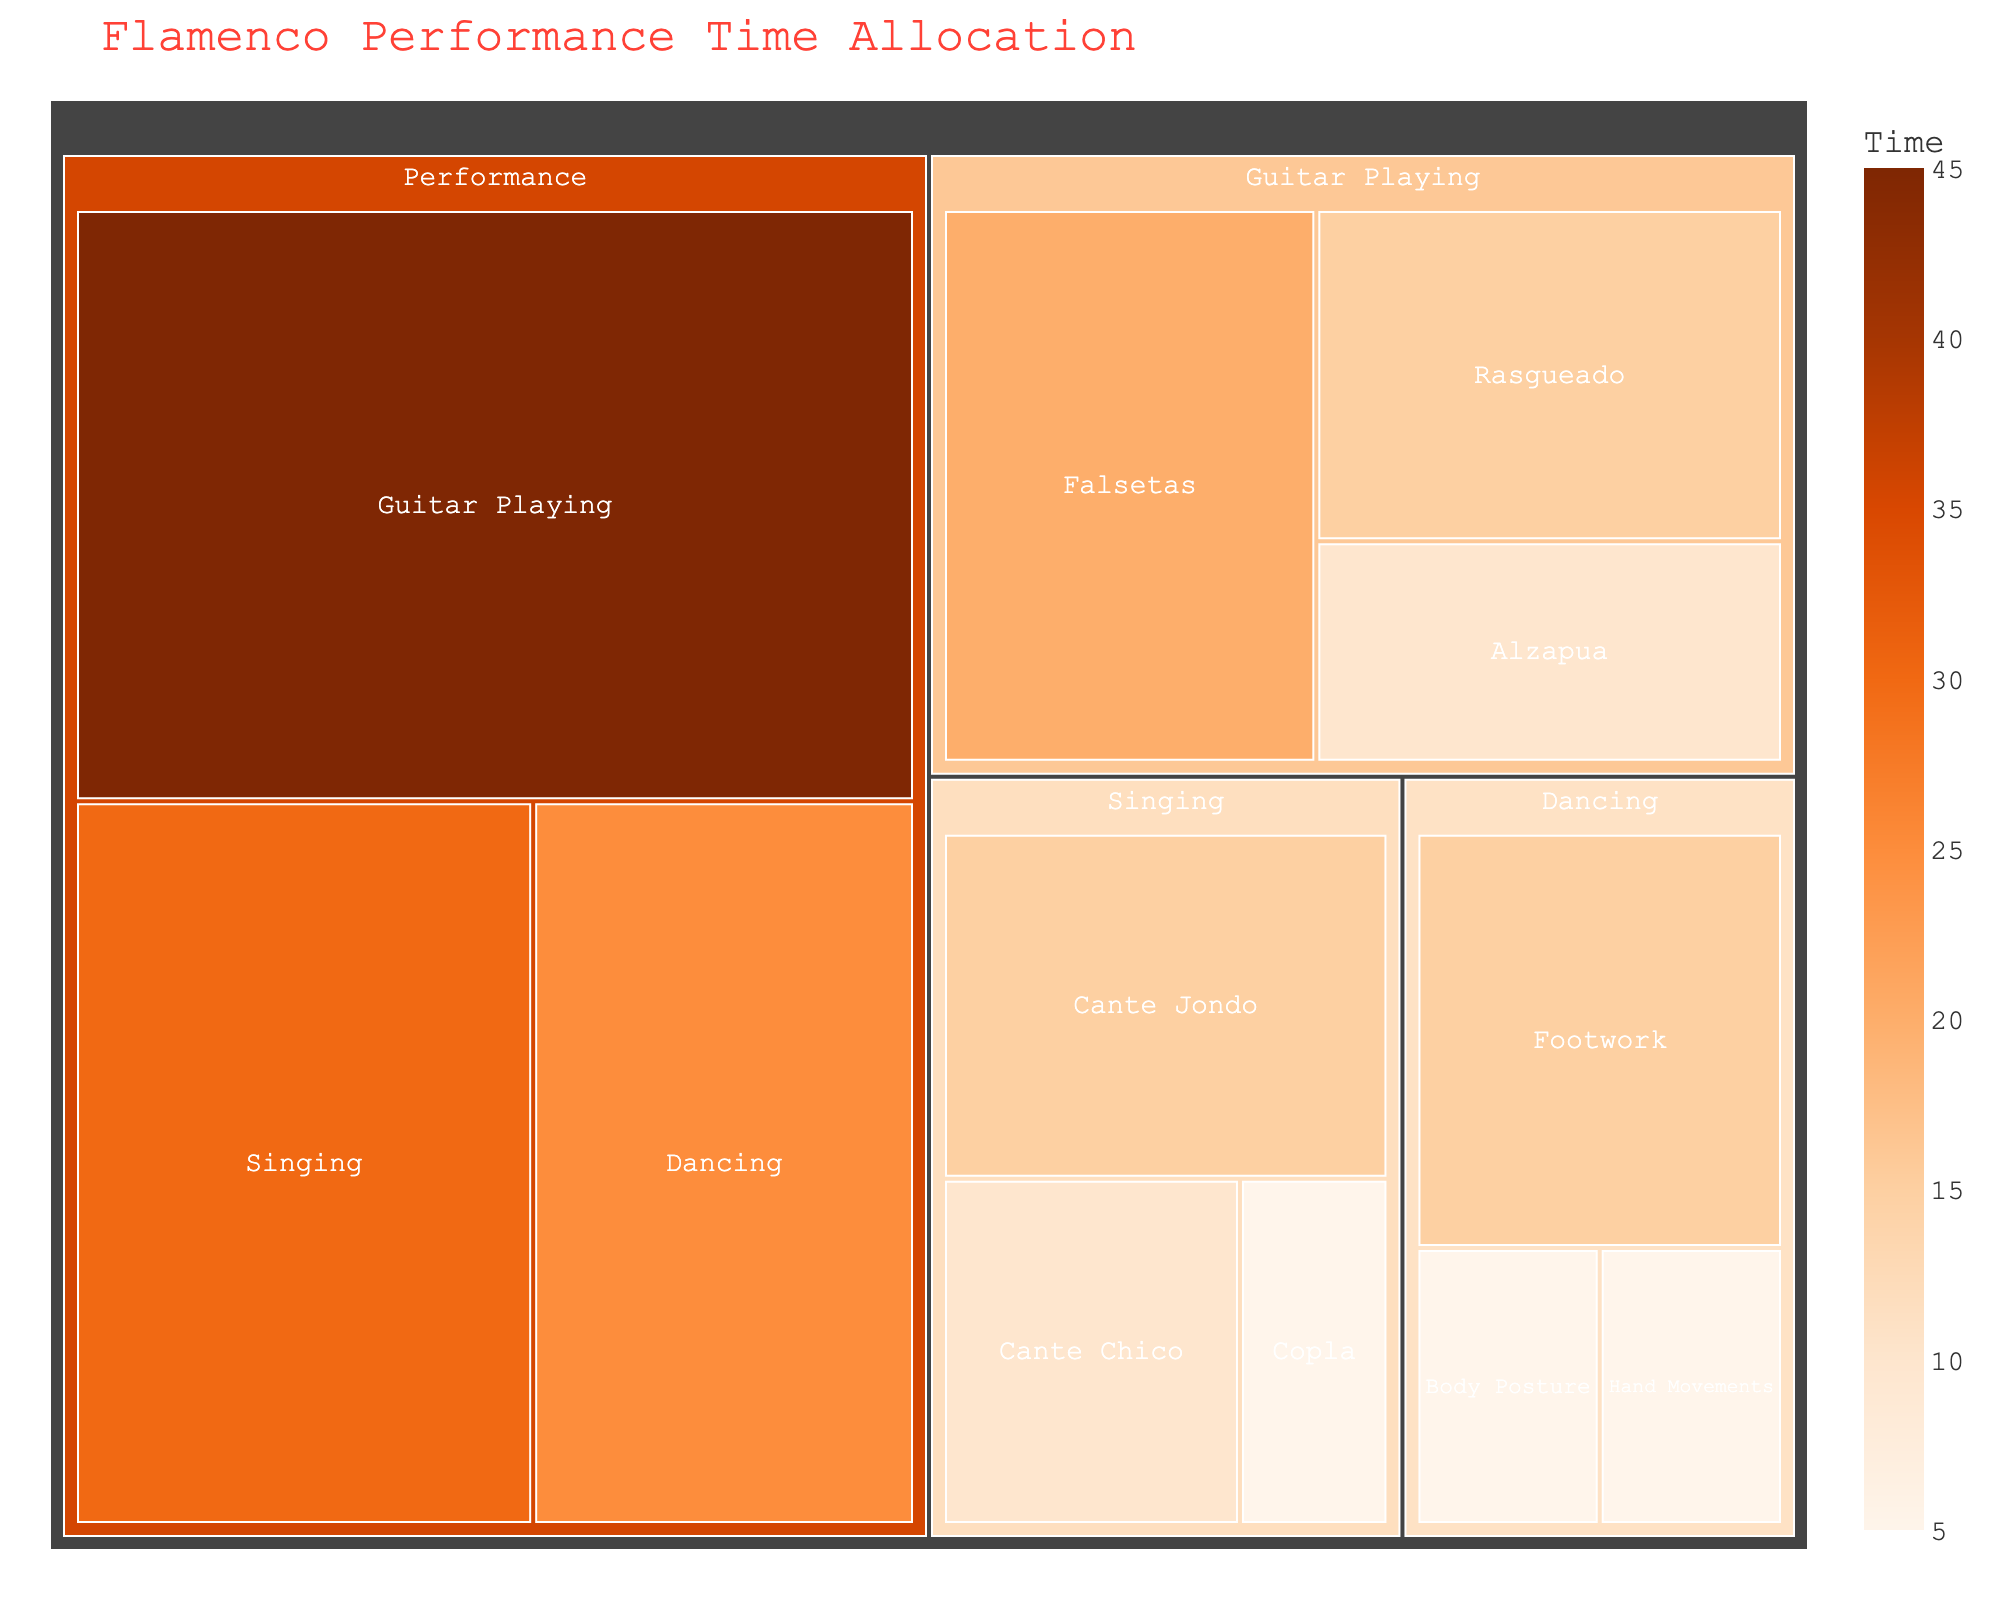What's the total time allocated to Flamenco Performance? To find the total time for Flamenco Performance, sum the times for singing, dancing, and guitar playing: 30 + 25 + 45 = 100 minutes.
Answer: 100 minutes Which subcategory of Guitar Playing has the most time? Look at the subcategories under Guitar Playing: Falsetas (20 min), Rasgueado (15 min), Alzapua (10 min). Falsetas has the most time.
Answer: Falsetas What is the ratio of time spent on Singing to Dancing? Time spent on Singing is 30 minutes. Time spent on Dancing is 25 minutes. The ratio is 30:25, which simplifies to 6:5.
Answer: 6:5 Which has more time allocated: Rasgueado or Cante Jondo? Rasgueado has 15 minutes, and Cante Jondo has 15 minutes. They have the same amount of time allocated.
Answer: Same amount What's the difference in time between guitar playing and singing? Time for Guitar Playing is 45 minutes. Time for Singing is 30 minutes. Difference: 45 - 30 = 15 minutes.
Answer: 15 minutes Is there any subcategory in Dancing that has the same time as the smallest Singing subcategory? In Singing, the smallest subcategory is Copla with 5 minutes. In Dancing, Hand Movements and Body Posture also have 5 minutes.
Answer: Yes What percentage of total Flamenco Performance time is spent on Guitar Playing? Total time for Flamenco Performance is 100 minutes. Time on Guitar Playing is 45 minutes. Percentage: (45/100) * 100 = 45%.
Answer: 45% Which subcategory inside Singing has the least amount of time? Within Singing, the subcategories are Cante Jondo (15 min), Cante Chico (10 min), Copla (5 min), with Copla having the least time.
Answer: Copla 